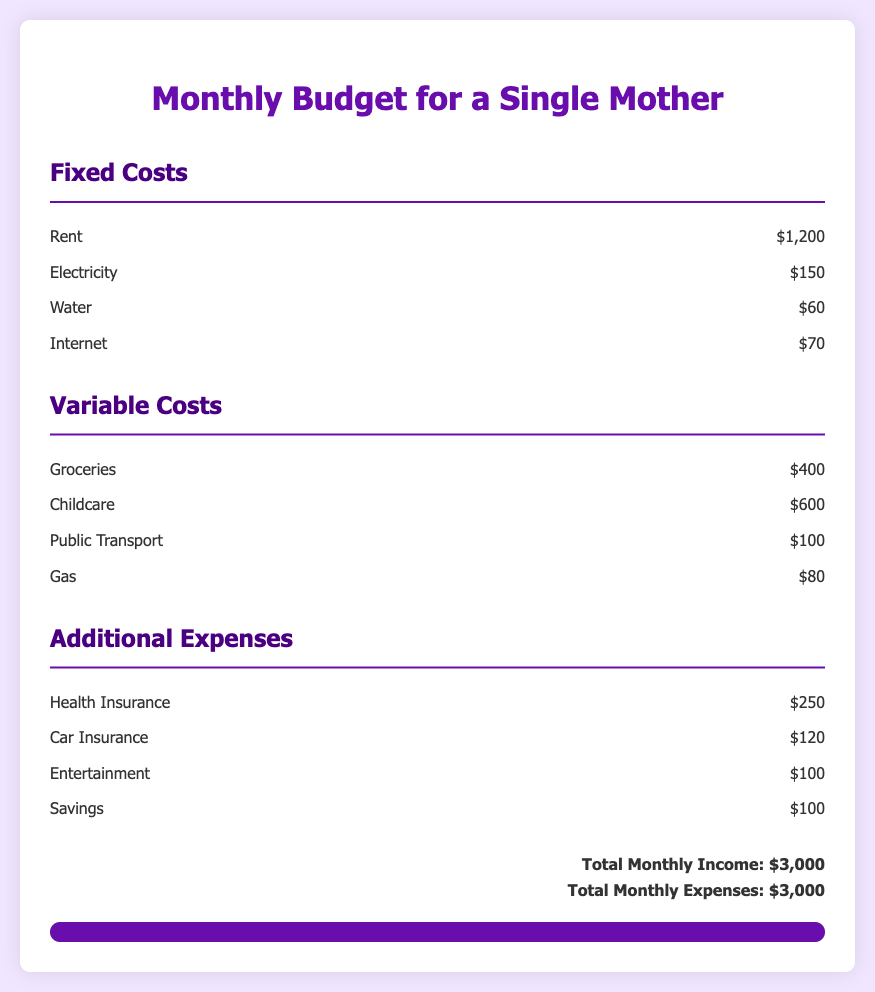What is the total monthly income? The total monthly income is explicitly stated in the document as $3,000.
Answer: $3,000 How much is spent on rent? The document lists rent as a fixed cost, which is $1,200.
Answer: $1,200 What is the amount allocated for groceries? Groceries are categorized under variable costs, with an allocation of $400.
Answer: $400 What is the total amount for childcare costs? Childcare costs are listed as $600 in the variable costs section.
Answer: $600 What are the combined total fixed costs? To find this, add all fixed costs: $1,200 (Rent) + $150 (Electricity) + $60 (Water) + $70 (Internet) = $1,480.
Answer: $1,480 How much is budgeted for health insurance? Health insurance is listed under additional expenses with a budget of $250.
Answer: $250 What is the total amount for variable costs? Total variable costs can be calculated as: $400 (Groceries) + $600 (Childcare) + $100 (Public Transport) + $80 (Gas) = $1,180.
Answer: $1,180 Which expense has the highest cost? The highest expense is rent, totaling $1,200.
Answer: Rent What is the total of additional expenses? Add the costs in the additional expenses section: $250 (Health Insurance) + $120 (Car Insurance) + $100 (Entertainment) + $100 (Savings) = $570.
Answer: $570 How much of the monthly income is spent? The total monthly expenses are equal to the income, both are $3,000.
Answer: $3,000 